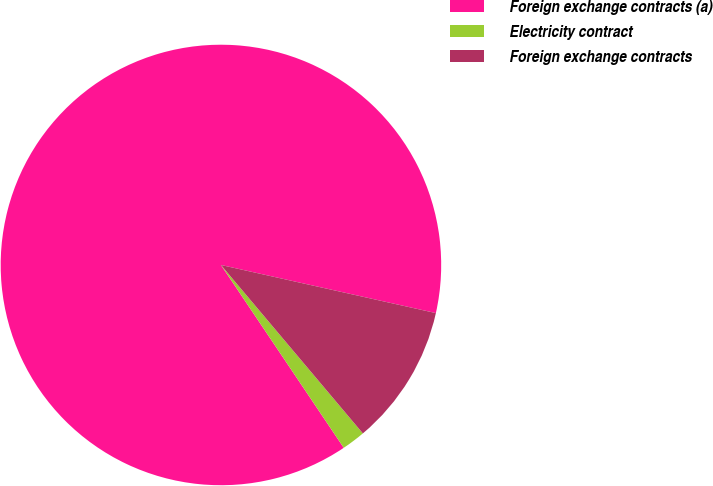Convert chart to OTSL. <chart><loc_0><loc_0><loc_500><loc_500><pie_chart><fcel>Foreign exchange contracts (a)<fcel>Electricity contract<fcel>Foreign exchange contracts<nl><fcel>87.92%<fcel>1.73%<fcel>10.35%<nl></chart> 